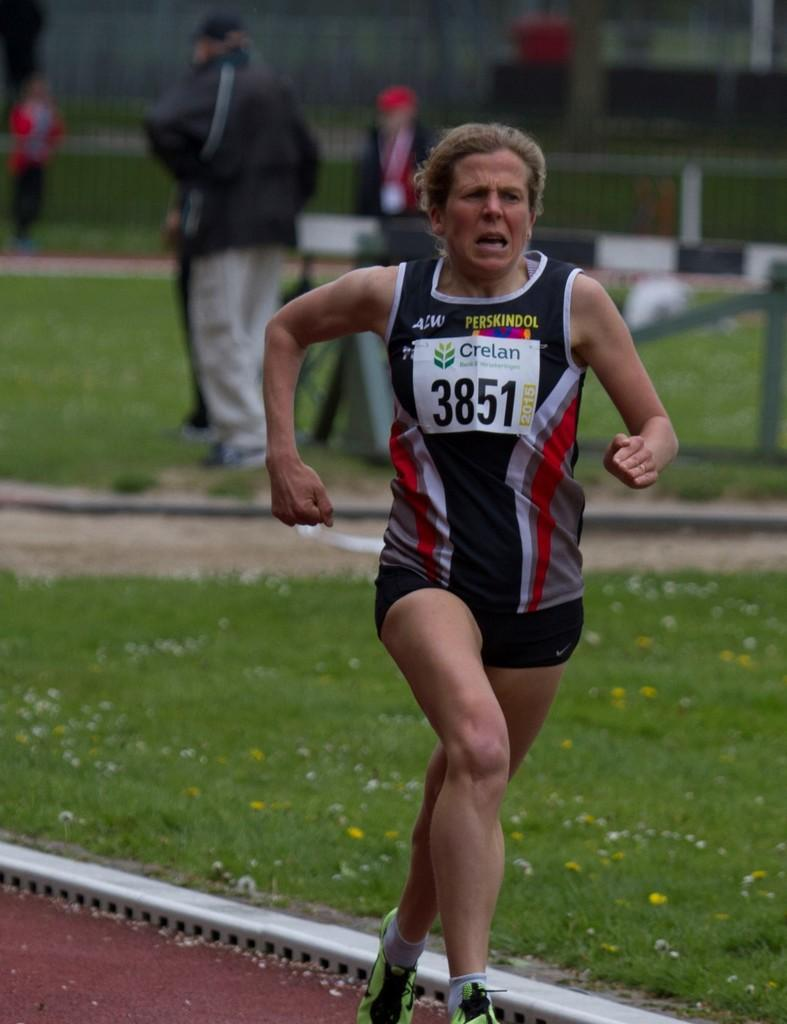What is the main action being performed by the person in the image? There is a person running in the image. What type of surface is the person running on? There is grass visible in the image, so the person is likely running on grass. Are there any other people present in the image? Yes, there are other people present in the image. What type of pot is being used to measure the person's speed in the image? There is no pot present in the image, nor is there any indication of measuring the person's speed. 